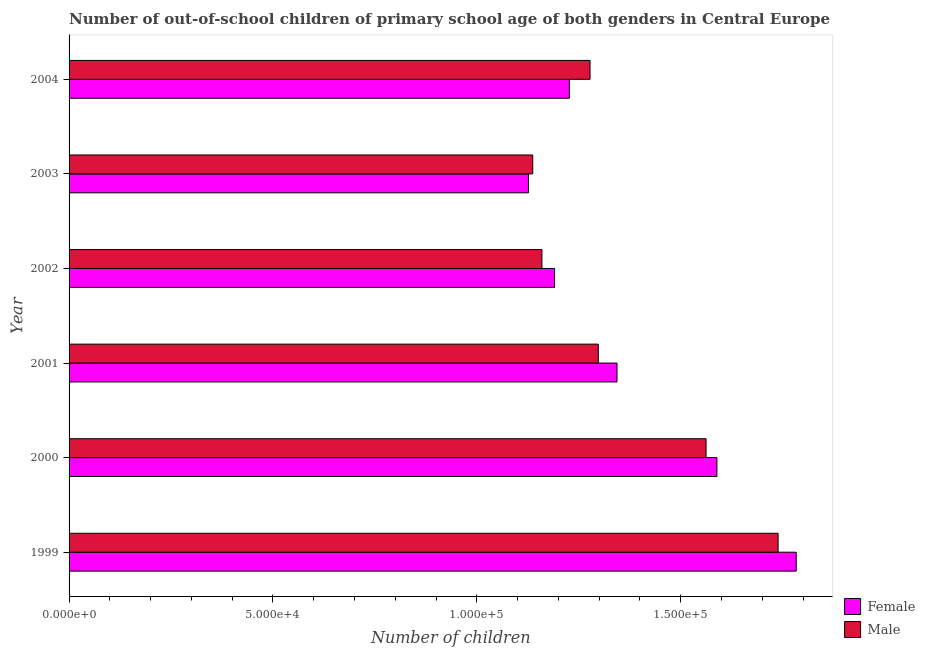How many different coloured bars are there?
Your answer should be very brief. 2. Are the number of bars per tick equal to the number of legend labels?
Keep it short and to the point. Yes. How many bars are there on the 6th tick from the top?
Provide a short and direct response. 2. What is the label of the 4th group of bars from the top?
Offer a very short reply. 2001. What is the number of female out-of-school students in 2001?
Make the answer very short. 1.34e+05. Across all years, what is the maximum number of female out-of-school students?
Your response must be concise. 1.78e+05. Across all years, what is the minimum number of male out-of-school students?
Your answer should be very brief. 1.14e+05. In which year was the number of male out-of-school students minimum?
Your answer should be very brief. 2003. What is the total number of male out-of-school students in the graph?
Offer a terse response. 8.17e+05. What is the difference between the number of male out-of-school students in 2001 and that in 2004?
Keep it short and to the point. 2026. What is the difference between the number of female out-of-school students in 1999 and the number of male out-of-school students in 2001?
Your answer should be very brief. 4.85e+04. What is the average number of female out-of-school students per year?
Ensure brevity in your answer.  1.38e+05. In the year 2002, what is the difference between the number of female out-of-school students and number of male out-of-school students?
Your answer should be compact. 3104. What is the ratio of the number of female out-of-school students in 1999 to that in 2002?
Provide a succinct answer. 1.5. Is the number of female out-of-school students in 1999 less than that in 2000?
Keep it short and to the point. No. Is the difference between the number of male out-of-school students in 1999 and 2004 greater than the difference between the number of female out-of-school students in 1999 and 2004?
Ensure brevity in your answer.  No. What is the difference between the highest and the second highest number of male out-of-school students?
Your answer should be very brief. 1.77e+04. What is the difference between the highest and the lowest number of female out-of-school students?
Provide a succinct answer. 6.57e+04. Is the sum of the number of female out-of-school students in 1999 and 2001 greater than the maximum number of male out-of-school students across all years?
Ensure brevity in your answer.  Yes. What does the 2nd bar from the bottom in 2003 represents?
Make the answer very short. Male. How many bars are there?
Offer a terse response. 12. Are all the bars in the graph horizontal?
Your answer should be very brief. Yes. How many years are there in the graph?
Give a very brief answer. 6. What is the difference between two consecutive major ticks on the X-axis?
Your answer should be compact. 5.00e+04. Does the graph contain any zero values?
Make the answer very short. No. Where does the legend appear in the graph?
Your response must be concise. Bottom right. How many legend labels are there?
Offer a terse response. 2. What is the title of the graph?
Offer a very short reply. Number of out-of-school children of primary school age of both genders in Central Europe. Does "Canada" appear as one of the legend labels in the graph?
Make the answer very short. No. What is the label or title of the X-axis?
Keep it short and to the point. Number of children. What is the label or title of the Y-axis?
Give a very brief answer. Year. What is the Number of children of Female in 1999?
Offer a very short reply. 1.78e+05. What is the Number of children of Male in 1999?
Provide a succinct answer. 1.74e+05. What is the Number of children in Female in 2000?
Offer a very short reply. 1.59e+05. What is the Number of children of Male in 2000?
Your answer should be very brief. 1.56e+05. What is the Number of children of Female in 2001?
Make the answer very short. 1.34e+05. What is the Number of children of Male in 2001?
Your response must be concise. 1.30e+05. What is the Number of children in Female in 2002?
Make the answer very short. 1.19e+05. What is the Number of children of Male in 2002?
Give a very brief answer. 1.16e+05. What is the Number of children in Female in 2003?
Your response must be concise. 1.13e+05. What is the Number of children in Male in 2003?
Offer a terse response. 1.14e+05. What is the Number of children in Female in 2004?
Offer a very short reply. 1.23e+05. What is the Number of children in Male in 2004?
Your answer should be very brief. 1.28e+05. Across all years, what is the maximum Number of children in Female?
Offer a very short reply. 1.78e+05. Across all years, what is the maximum Number of children of Male?
Provide a succinct answer. 1.74e+05. Across all years, what is the minimum Number of children of Female?
Provide a short and direct response. 1.13e+05. Across all years, what is the minimum Number of children of Male?
Make the answer very short. 1.14e+05. What is the total Number of children of Female in the graph?
Offer a terse response. 8.26e+05. What is the total Number of children of Male in the graph?
Keep it short and to the point. 8.17e+05. What is the difference between the Number of children of Female in 1999 and that in 2000?
Make the answer very short. 1.94e+04. What is the difference between the Number of children of Male in 1999 and that in 2000?
Keep it short and to the point. 1.77e+04. What is the difference between the Number of children in Female in 1999 and that in 2001?
Offer a very short reply. 4.40e+04. What is the difference between the Number of children in Male in 1999 and that in 2001?
Provide a succinct answer. 4.41e+04. What is the difference between the Number of children in Female in 1999 and that in 2002?
Provide a succinct answer. 5.93e+04. What is the difference between the Number of children in Male in 1999 and that in 2002?
Your answer should be very brief. 5.79e+04. What is the difference between the Number of children of Female in 1999 and that in 2003?
Give a very brief answer. 6.57e+04. What is the difference between the Number of children in Male in 1999 and that in 2003?
Offer a very short reply. 6.02e+04. What is the difference between the Number of children in Female in 1999 and that in 2004?
Your response must be concise. 5.56e+04. What is the difference between the Number of children of Male in 1999 and that in 2004?
Your answer should be very brief. 4.61e+04. What is the difference between the Number of children in Female in 2000 and that in 2001?
Offer a terse response. 2.45e+04. What is the difference between the Number of children in Male in 2000 and that in 2001?
Your answer should be compact. 2.64e+04. What is the difference between the Number of children in Female in 2000 and that in 2002?
Your response must be concise. 3.98e+04. What is the difference between the Number of children in Male in 2000 and that in 2002?
Keep it short and to the point. 4.03e+04. What is the difference between the Number of children in Female in 2000 and that in 2003?
Provide a succinct answer. 4.62e+04. What is the difference between the Number of children in Male in 2000 and that in 2003?
Provide a succinct answer. 4.25e+04. What is the difference between the Number of children in Female in 2000 and that in 2004?
Offer a terse response. 3.62e+04. What is the difference between the Number of children in Male in 2000 and that in 2004?
Your response must be concise. 2.85e+04. What is the difference between the Number of children of Female in 2001 and that in 2002?
Make the answer very short. 1.53e+04. What is the difference between the Number of children of Male in 2001 and that in 2002?
Offer a terse response. 1.38e+04. What is the difference between the Number of children of Female in 2001 and that in 2003?
Your response must be concise. 2.17e+04. What is the difference between the Number of children of Male in 2001 and that in 2003?
Your response must be concise. 1.61e+04. What is the difference between the Number of children of Female in 2001 and that in 2004?
Offer a very short reply. 1.17e+04. What is the difference between the Number of children of Male in 2001 and that in 2004?
Provide a short and direct response. 2026. What is the difference between the Number of children of Female in 2002 and that in 2003?
Ensure brevity in your answer.  6415. What is the difference between the Number of children in Male in 2002 and that in 2003?
Provide a succinct answer. 2258. What is the difference between the Number of children in Female in 2002 and that in 2004?
Give a very brief answer. -3624. What is the difference between the Number of children of Male in 2002 and that in 2004?
Make the answer very short. -1.18e+04. What is the difference between the Number of children in Female in 2003 and that in 2004?
Ensure brevity in your answer.  -1.00e+04. What is the difference between the Number of children in Male in 2003 and that in 2004?
Provide a short and direct response. -1.41e+04. What is the difference between the Number of children in Female in 1999 and the Number of children in Male in 2000?
Offer a very short reply. 2.21e+04. What is the difference between the Number of children in Female in 1999 and the Number of children in Male in 2001?
Your response must be concise. 4.85e+04. What is the difference between the Number of children of Female in 1999 and the Number of children of Male in 2002?
Ensure brevity in your answer.  6.24e+04. What is the difference between the Number of children of Female in 1999 and the Number of children of Male in 2003?
Keep it short and to the point. 6.46e+04. What is the difference between the Number of children of Female in 1999 and the Number of children of Male in 2004?
Provide a short and direct response. 5.06e+04. What is the difference between the Number of children of Female in 2000 and the Number of children of Male in 2001?
Make the answer very short. 2.91e+04. What is the difference between the Number of children in Female in 2000 and the Number of children in Male in 2002?
Your answer should be compact. 4.29e+04. What is the difference between the Number of children in Female in 2000 and the Number of children in Male in 2003?
Keep it short and to the point. 4.52e+04. What is the difference between the Number of children of Female in 2000 and the Number of children of Male in 2004?
Your response must be concise. 3.11e+04. What is the difference between the Number of children in Female in 2001 and the Number of children in Male in 2002?
Offer a very short reply. 1.84e+04. What is the difference between the Number of children in Female in 2001 and the Number of children in Male in 2003?
Your answer should be very brief. 2.07e+04. What is the difference between the Number of children in Female in 2001 and the Number of children in Male in 2004?
Your response must be concise. 6614. What is the difference between the Number of children in Female in 2002 and the Number of children in Male in 2003?
Your answer should be compact. 5362. What is the difference between the Number of children in Female in 2002 and the Number of children in Male in 2004?
Make the answer very short. -8691. What is the difference between the Number of children of Female in 2003 and the Number of children of Male in 2004?
Keep it short and to the point. -1.51e+04. What is the average Number of children of Female per year?
Offer a terse response. 1.38e+05. What is the average Number of children in Male per year?
Provide a short and direct response. 1.36e+05. In the year 1999, what is the difference between the Number of children in Female and Number of children in Male?
Your answer should be compact. 4448. In the year 2000, what is the difference between the Number of children of Female and Number of children of Male?
Ensure brevity in your answer.  2661. In the year 2001, what is the difference between the Number of children in Female and Number of children in Male?
Give a very brief answer. 4588. In the year 2002, what is the difference between the Number of children in Female and Number of children in Male?
Offer a very short reply. 3104. In the year 2003, what is the difference between the Number of children in Female and Number of children in Male?
Offer a very short reply. -1053. In the year 2004, what is the difference between the Number of children in Female and Number of children in Male?
Provide a succinct answer. -5067. What is the ratio of the Number of children in Female in 1999 to that in 2000?
Your response must be concise. 1.12. What is the ratio of the Number of children in Male in 1999 to that in 2000?
Your answer should be very brief. 1.11. What is the ratio of the Number of children of Female in 1999 to that in 2001?
Your response must be concise. 1.33. What is the ratio of the Number of children of Male in 1999 to that in 2001?
Your response must be concise. 1.34. What is the ratio of the Number of children of Female in 1999 to that in 2002?
Your response must be concise. 1.5. What is the ratio of the Number of children of Male in 1999 to that in 2002?
Ensure brevity in your answer.  1.5. What is the ratio of the Number of children of Female in 1999 to that in 2003?
Your answer should be compact. 1.58. What is the ratio of the Number of children of Male in 1999 to that in 2003?
Your answer should be compact. 1.53. What is the ratio of the Number of children in Female in 1999 to that in 2004?
Provide a short and direct response. 1.45. What is the ratio of the Number of children of Male in 1999 to that in 2004?
Keep it short and to the point. 1.36. What is the ratio of the Number of children in Female in 2000 to that in 2001?
Offer a terse response. 1.18. What is the ratio of the Number of children in Male in 2000 to that in 2001?
Provide a short and direct response. 1.2. What is the ratio of the Number of children in Female in 2000 to that in 2002?
Your response must be concise. 1.33. What is the ratio of the Number of children of Male in 2000 to that in 2002?
Ensure brevity in your answer.  1.35. What is the ratio of the Number of children of Female in 2000 to that in 2003?
Your answer should be very brief. 1.41. What is the ratio of the Number of children of Male in 2000 to that in 2003?
Offer a very short reply. 1.37. What is the ratio of the Number of children in Female in 2000 to that in 2004?
Keep it short and to the point. 1.29. What is the ratio of the Number of children in Male in 2000 to that in 2004?
Provide a succinct answer. 1.22. What is the ratio of the Number of children of Female in 2001 to that in 2002?
Give a very brief answer. 1.13. What is the ratio of the Number of children in Male in 2001 to that in 2002?
Your answer should be compact. 1.12. What is the ratio of the Number of children in Female in 2001 to that in 2003?
Provide a short and direct response. 1.19. What is the ratio of the Number of children of Male in 2001 to that in 2003?
Make the answer very short. 1.14. What is the ratio of the Number of children of Female in 2001 to that in 2004?
Your answer should be very brief. 1.1. What is the ratio of the Number of children in Male in 2001 to that in 2004?
Provide a short and direct response. 1.02. What is the ratio of the Number of children of Female in 2002 to that in 2003?
Ensure brevity in your answer.  1.06. What is the ratio of the Number of children of Male in 2002 to that in 2003?
Give a very brief answer. 1.02. What is the ratio of the Number of children in Female in 2002 to that in 2004?
Offer a very short reply. 0.97. What is the ratio of the Number of children in Male in 2002 to that in 2004?
Your answer should be very brief. 0.91. What is the ratio of the Number of children of Female in 2003 to that in 2004?
Offer a very short reply. 0.92. What is the ratio of the Number of children in Male in 2003 to that in 2004?
Your answer should be very brief. 0.89. What is the difference between the highest and the second highest Number of children of Female?
Give a very brief answer. 1.94e+04. What is the difference between the highest and the second highest Number of children of Male?
Keep it short and to the point. 1.77e+04. What is the difference between the highest and the lowest Number of children of Female?
Your answer should be compact. 6.57e+04. What is the difference between the highest and the lowest Number of children of Male?
Make the answer very short. 6.02e+04. 